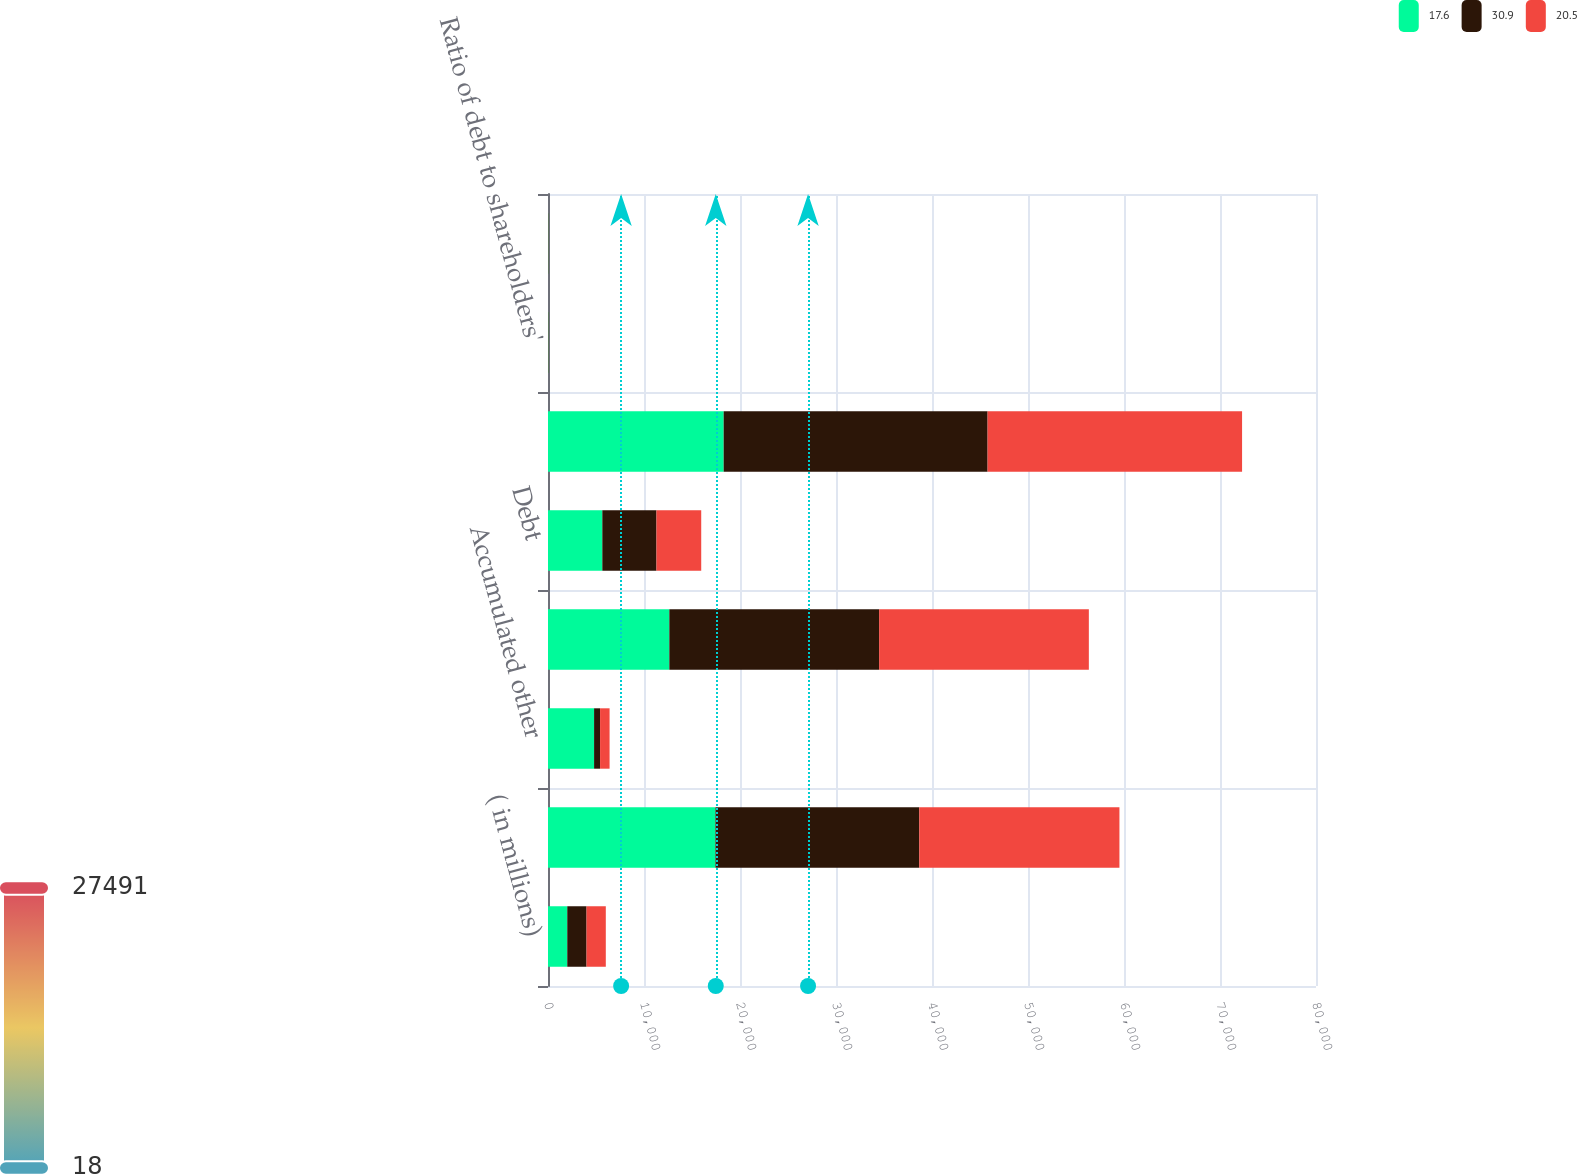Convert chart to OTSL. <chart><loc_0><loc_0><loc_500><loc_500><stacked_bar_chart><ecel><fcel>( in millions)<fcel>Common stock retained income<fcel>Accumulated other<fcel>Total shareholders' equity<fcel>Debt<fcel>Total capital resources<fcel>Ratio of debt to shareholders'<fcel>Ratio of debt to capital<nl><fcel>17.6<fcel>2008<fcel>17442<fcel>4801<fcel>12641<fcel>5659<fcel>18300<fcel>44.8<fcel>30.9<nl><fcel>30.9<fcel>2007<fcel>21228<fcel>623<fcel>21851<fcel>5640<fcel>27491<fcel>25.8<fcel>20.5<nl><fcel>20.5<fcel>2006<fcel>20855<fcel>991<fcel>21846<fcel>4662<fcel>26508<fcel>21.3<fcel>17.6<nl></chart> 